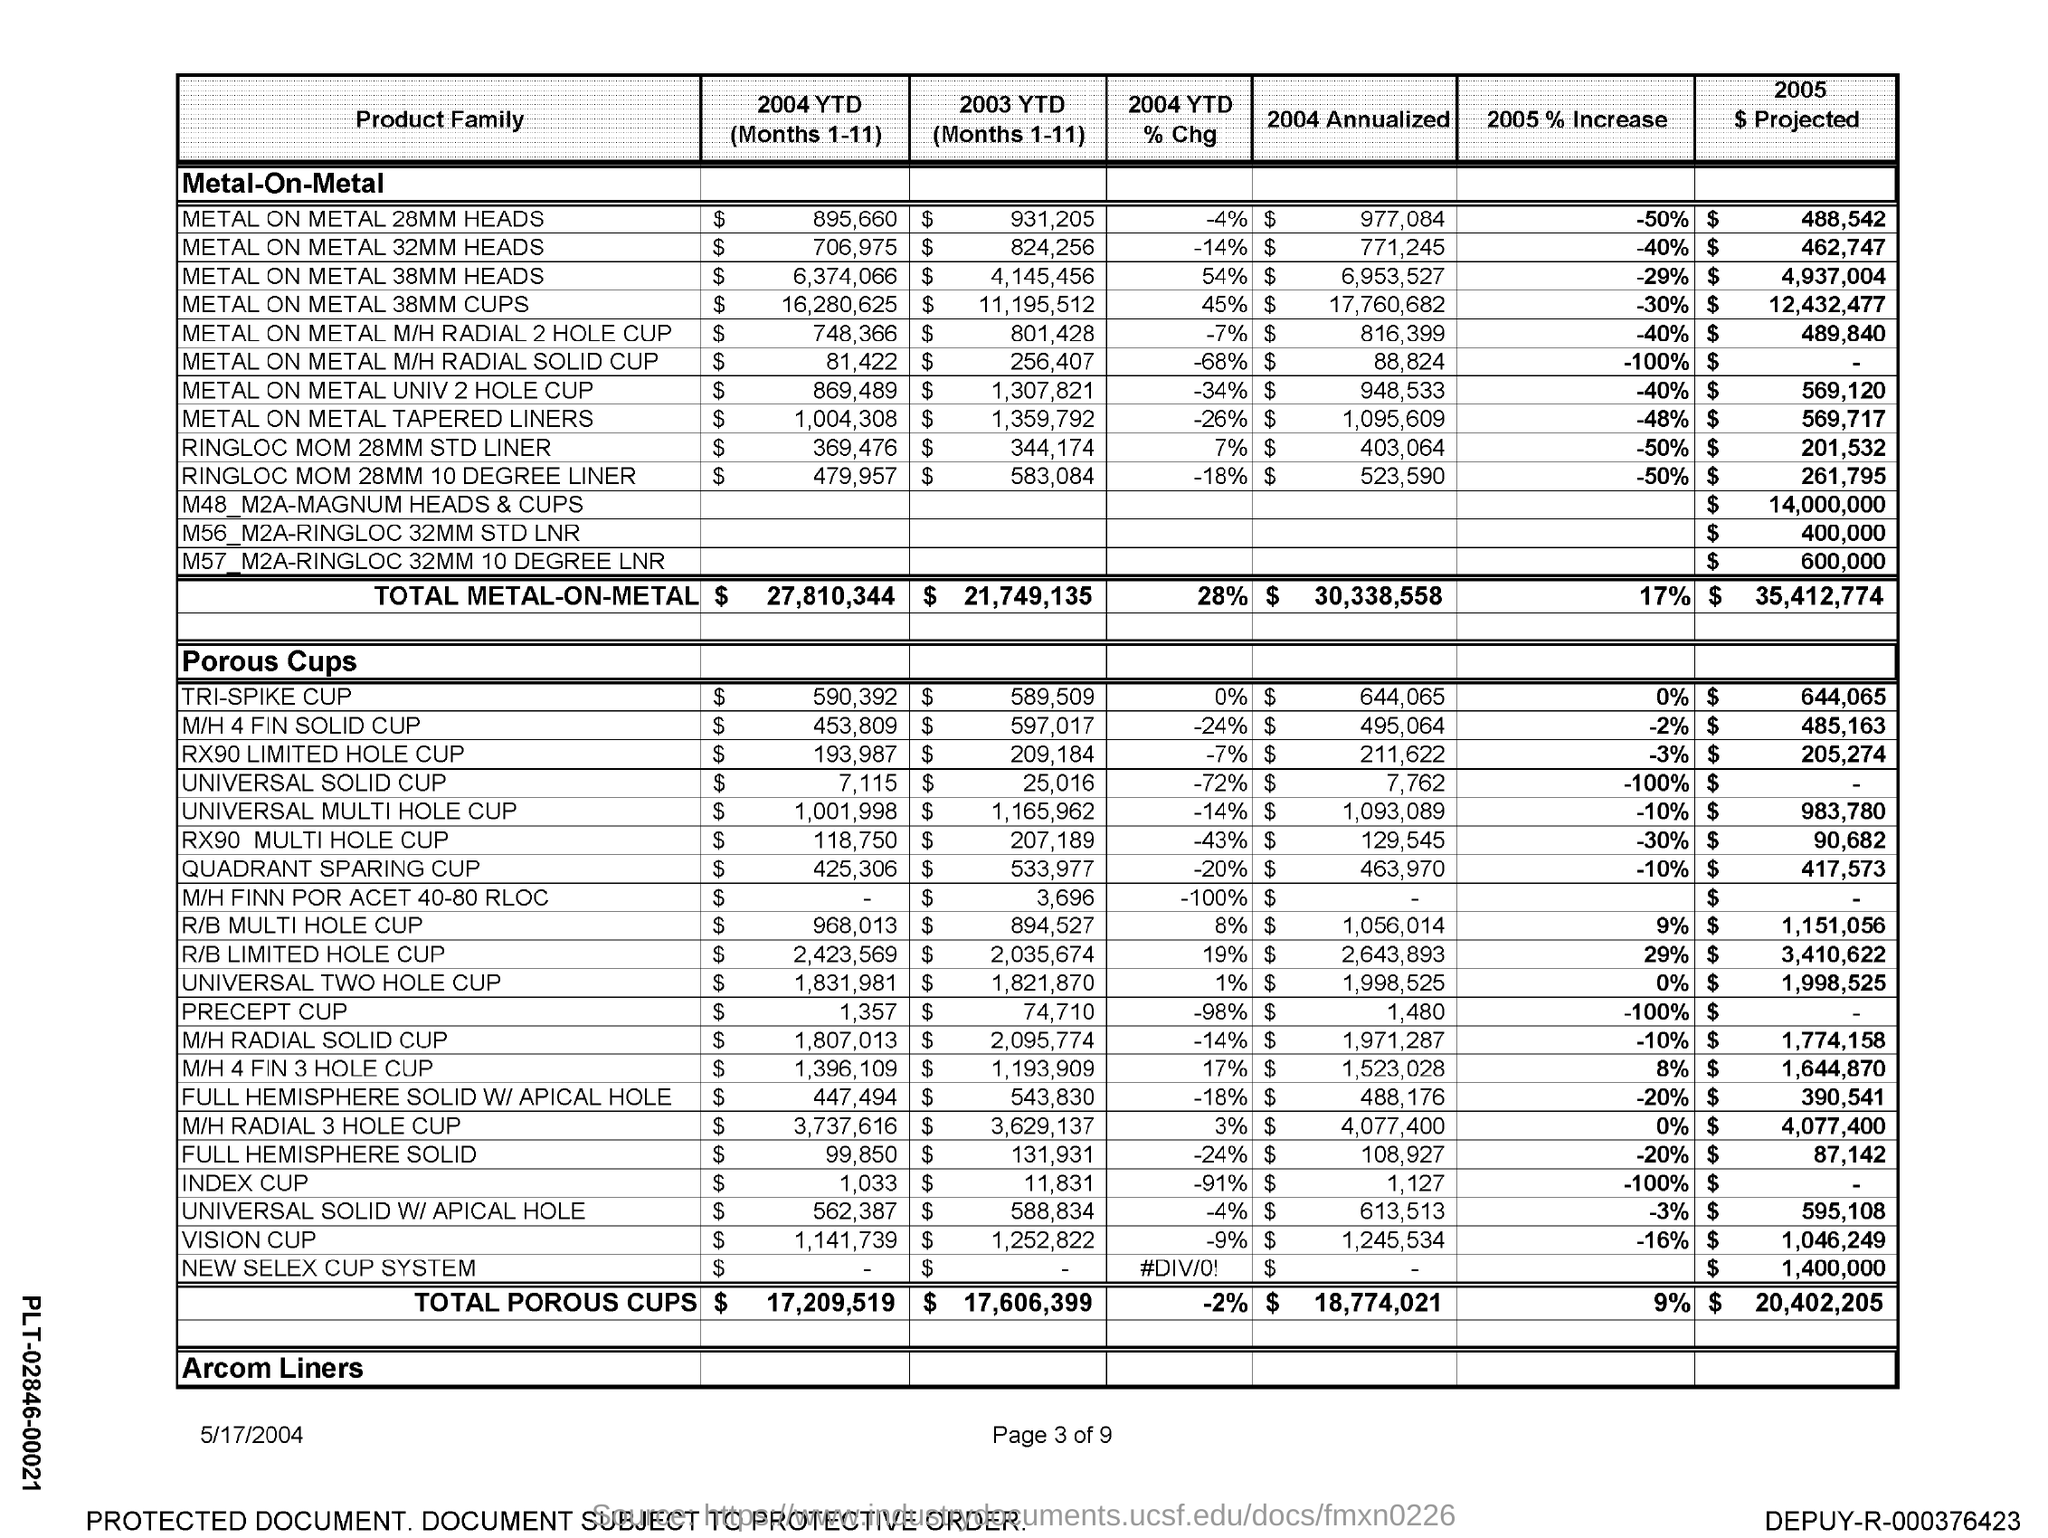What is the total metal-on-metal 2005% increase?
Offer a very short reply. 17%. 